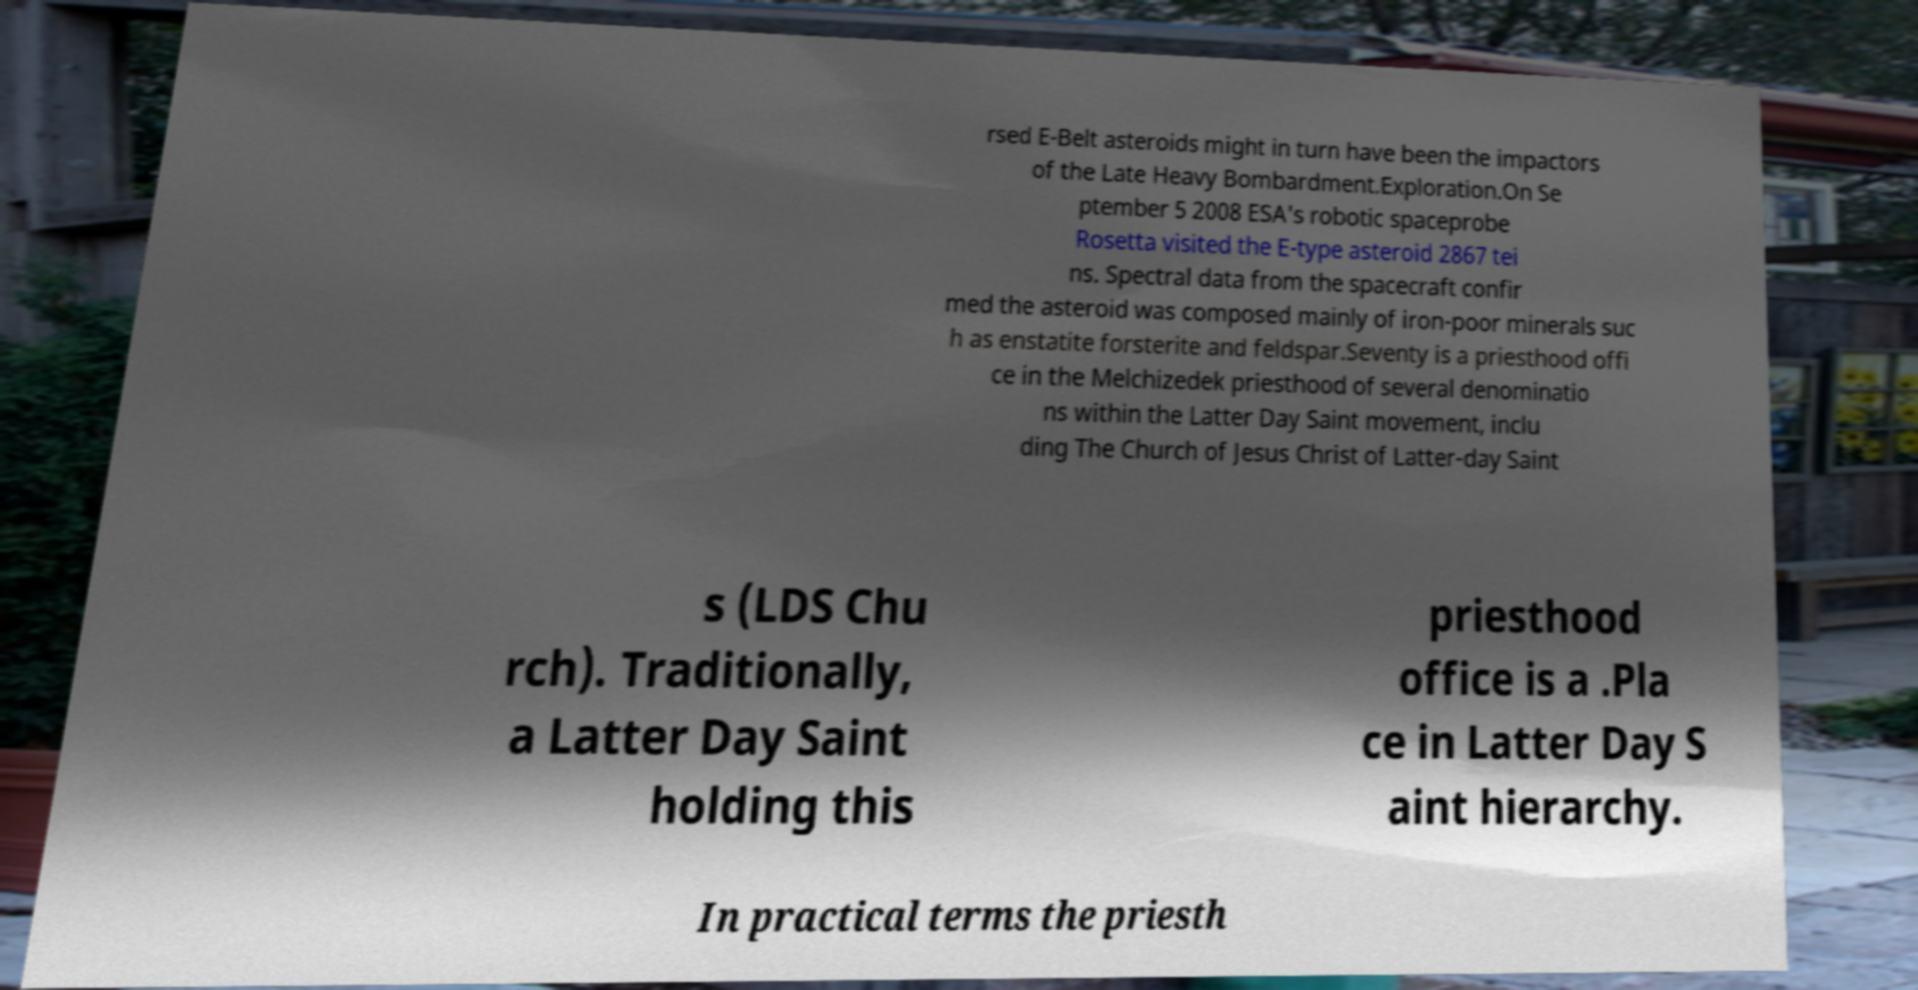There's text embedded in this image that I need extracted. Can you transcribe it verbatim? rsed E-Belt asteroids might in turn have been the impactors of the Late Heavy Bombardment.Exploration.On Se ptember 5 2008 ESA's robotic spaceprobe Rosetta visited the E-type asteroid 2867 tei ns. Spectral data from the spacecraft confir med the asteroid was composed mainly of iron-poor minerals suc h as enstatite forsterite and feldspar.Seventy is a priesthood offi ce in the Melchizedek priesthood of several denominatio ns within the Latter Day Saint movement, inclu ding The Church of Jesus Christ of Latter-day Saint s (LDS Chu rch). Traditionally, a Latter Day Saint holding this priesthood office is a .Pla ce in Latter Day S aint hierarchy. In practical terms the priesth 